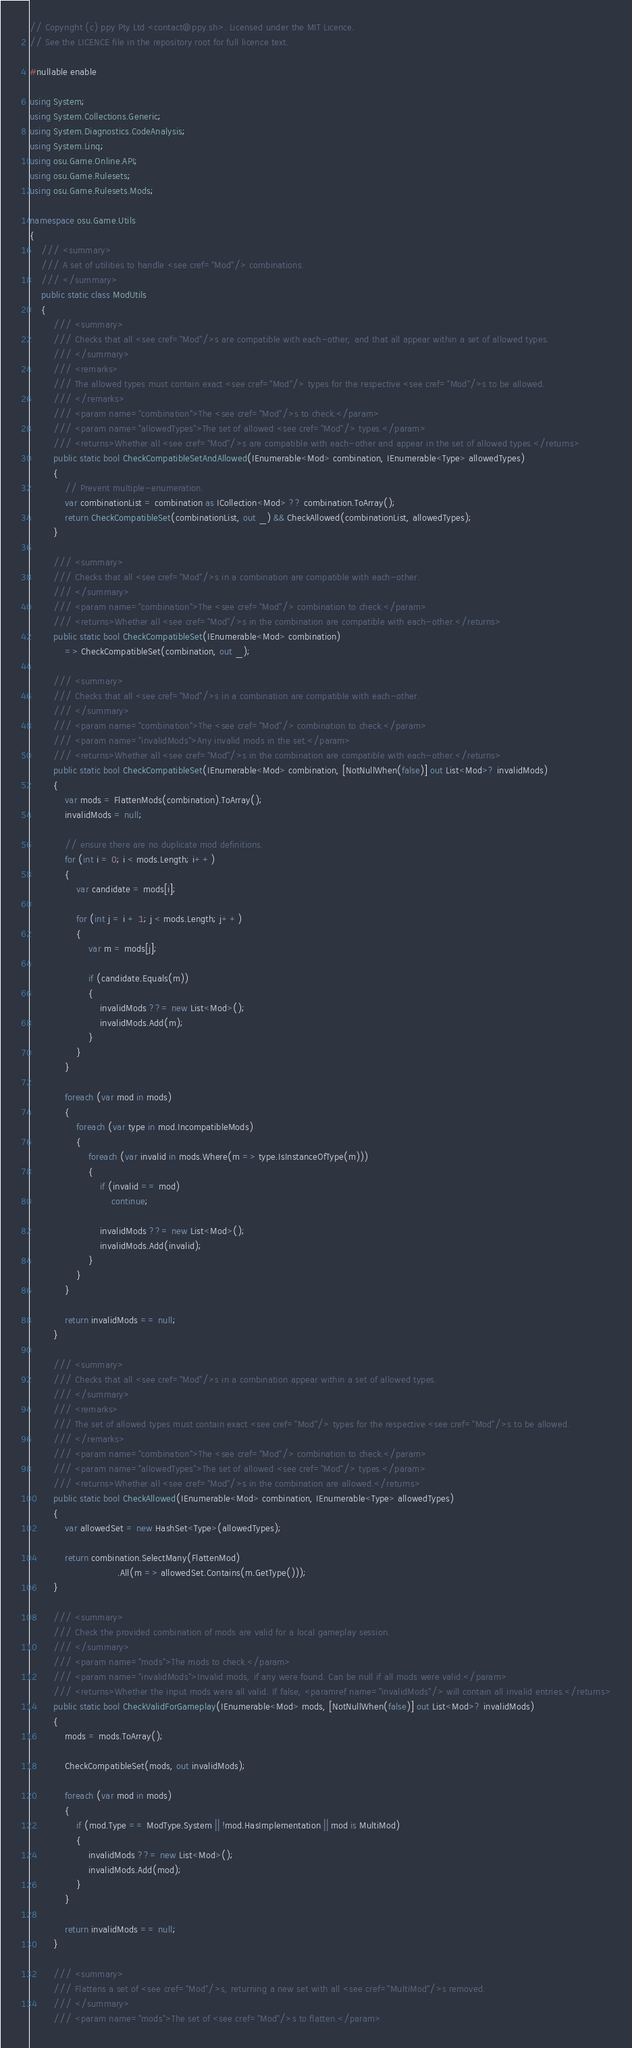Convert code to text. <code><loc_0><loc_0><loc_500><loc_500><_C#_>// Copyright (c) ppy Pty Ltd <contact@ppy.sh>. Licensed under the MIT Licence.
// See the LICENCE file in the repository root for full licence text.

#nullable enable

using System;
using System.Collections.Generic;
using System.Diagnostics.CodeAnalysis;
using System.Linq;
using osu.Game.Online.API;
using osu.Game.Rulesets;
using osu.Game.Rulesets.Mods;

namespace osu.Game.Utils
{
    /// <summary>
    /// A set of utilities to handle <see cref="Mod"/> combinations.
    /// </summary>
    public static class ModUtils
    {
        /// <summary>
        /// Checks that all <see cref="Mod"/>s are compatible with each-other, and that all appear within a set of allowed types.
        /// </summary>
        /// <remarks>
        /// The allowed types must contain exact <see cref="Mod"/> types for the respective <see cref="Mod"/>s to be allowed.
        /// </remarks>
        /// <param name="combination">The <see cref="Mod"/>s to check.</param>
        /// <param name="allowedTypes">The set of allowed <see cref="Mod"/> types.</param>
        /// <returns>Whether all <see cref="Mod"/>s are compatible with each-other and appear in the set of allowed types.</returns>
        public static bool CheckCompatibleSetAndAllowed(IEnumerable<Mod> combination, IEnumerable<Type> allowedTypes)
        {
            // Prevent multiple-enumeration.
            var combinationList = combination as ICollection<Mod> ?? combination.ToArray();
            return CheckCompatibleSet(combinationList, out _) && CheckAllowed(combinationList, allowedTypes);
        }

        /// <summary>
        /// Checks that all <see cref="Mod"/>s in a combination are compatible with each-other.
        /// </summary>
        /// <param name="combination">The <see cref="Mod"/> combination to check.</param>
        /// <returns>Whether all <see cref="Mod"/>s in the combination are compatible with each-other.</returns>
        public static bool CheckCompatibleSet(IEnumerable<Mod> combination)
            => CheckCompatibleSet(combination, out _);

        /// <summary>
        /// Checks that all <see cref="Mod"/>s in a combination are compatible with each-other.
        /// </summary>
        /// <param name="combination">The <see cref="Mod"/> combination to check.</param>
        /// <param name="invalidMods">Any invalid mods in the set.</param>
        /// <returns>Whether all <see cref="Mod"/>s in the combination are compatible with each-other.</returns>
        public static bool CheckCompatibleSet(IEnumerable<Mod> combination, [NotNullWhen(false)] out List<Mod>? invalidMods)
        {
            var mods = FlattenMods(combination).ToArray();
            invalidMods = null;

            // ensure there are no duplicate mod definitions.
            for (int i = 0; i < mods.Length; i++)
            {
                var candidate = mods[i];

                for (int j = i + 1; j < mods.Length; j++)
                {
                    var m = mods[j];

                    if (candidate.Equals(m))
                    {
                        invalidMods ??= new List<Mod>();
                        invalidMods.Add(m);
                    }
                }
            }

            foreach (var mod in mods)
            {
                foreach (var type in mod.IncompatibleMods)
                {
                    foreach (var invalid in mods.Where(m => type.IsInstanceOfType(m)))
                    {
                        if (invalid == mod)
                            continue;

                        invalidMods ??= new List<Mod>();
                        invalidMods.Add(invalid);
                    }
                }
            }

            return invalidMods == null;
        }

        /// <summary>
        /// Checks that all <see cref="Mod"/>s in a combination appear within a set of allowed types.
        /// </summary>
        /// <remarks>
        /// The set of allowed types must contain exact <see cref="Mod"/> types for the respective <see cref="Mod"/>s to be allowed.
        /// </remarks>
        /// <param name="combination">The <see cref="Mod"/> combination to check.</param>
        /// <param name="allowedTypes">The set of allowed <see cref="Mod"/> types.</param>
        /// <returns>Whether all <see cref="Mod"/>s in the combination are allowed.</returns>
        public static bool CheckAllowed(IEnumerable<Mod> combination, IEnumerable<Type> allowedTypes)
        {
            var allowedSet = new HashSet<Type>(allowedTypes);

            return combination.SelectMany(FlattenMod)
                              .All(m => allowedSet.Contains(m.GetType()));
        }

        /// <summary>
        /// Check the provided combination of mods are valid for a local gameplay session.
        /// </summary>
        /// <param name="mods">The mods to check.</param>
        /// <param name="invalidMods">Invalid mods, if any were found. Can be null if all mods were valid.</param>
        /// <returns>Whether the input mods were all valid. If false, <paramref name="invalidMods"/> will contain all invalid entries.</returns>
        public static bool CheckValidForGameplay(IEnumerable<Mod> mods, [NotNullWhen(false)] out List<Mod>? invalidMods)
        {
            mods = mods.ToArray();

            CheckCompatibleSet(mods, out invalidMods);

            foreach (var mod in mods)
            {
                if (mod.Type == ModType.System || !mod.HasImplementation || mod is MultiMod)
                {
                    invalidMods ??= new List<Mod>();
                    invalidMods.Add(mod);
                }
            }

            return invalidMods == null;
        }

        /// <summary>
        /// Flattens a set of <see cref="Mod"/>s, returning a new set with all <see cref="MultiMod"/>s removed.
        /// </summary>
        /// <param name="mods">The set of <see cref="Mod"/>s to flatten.</param></code> 